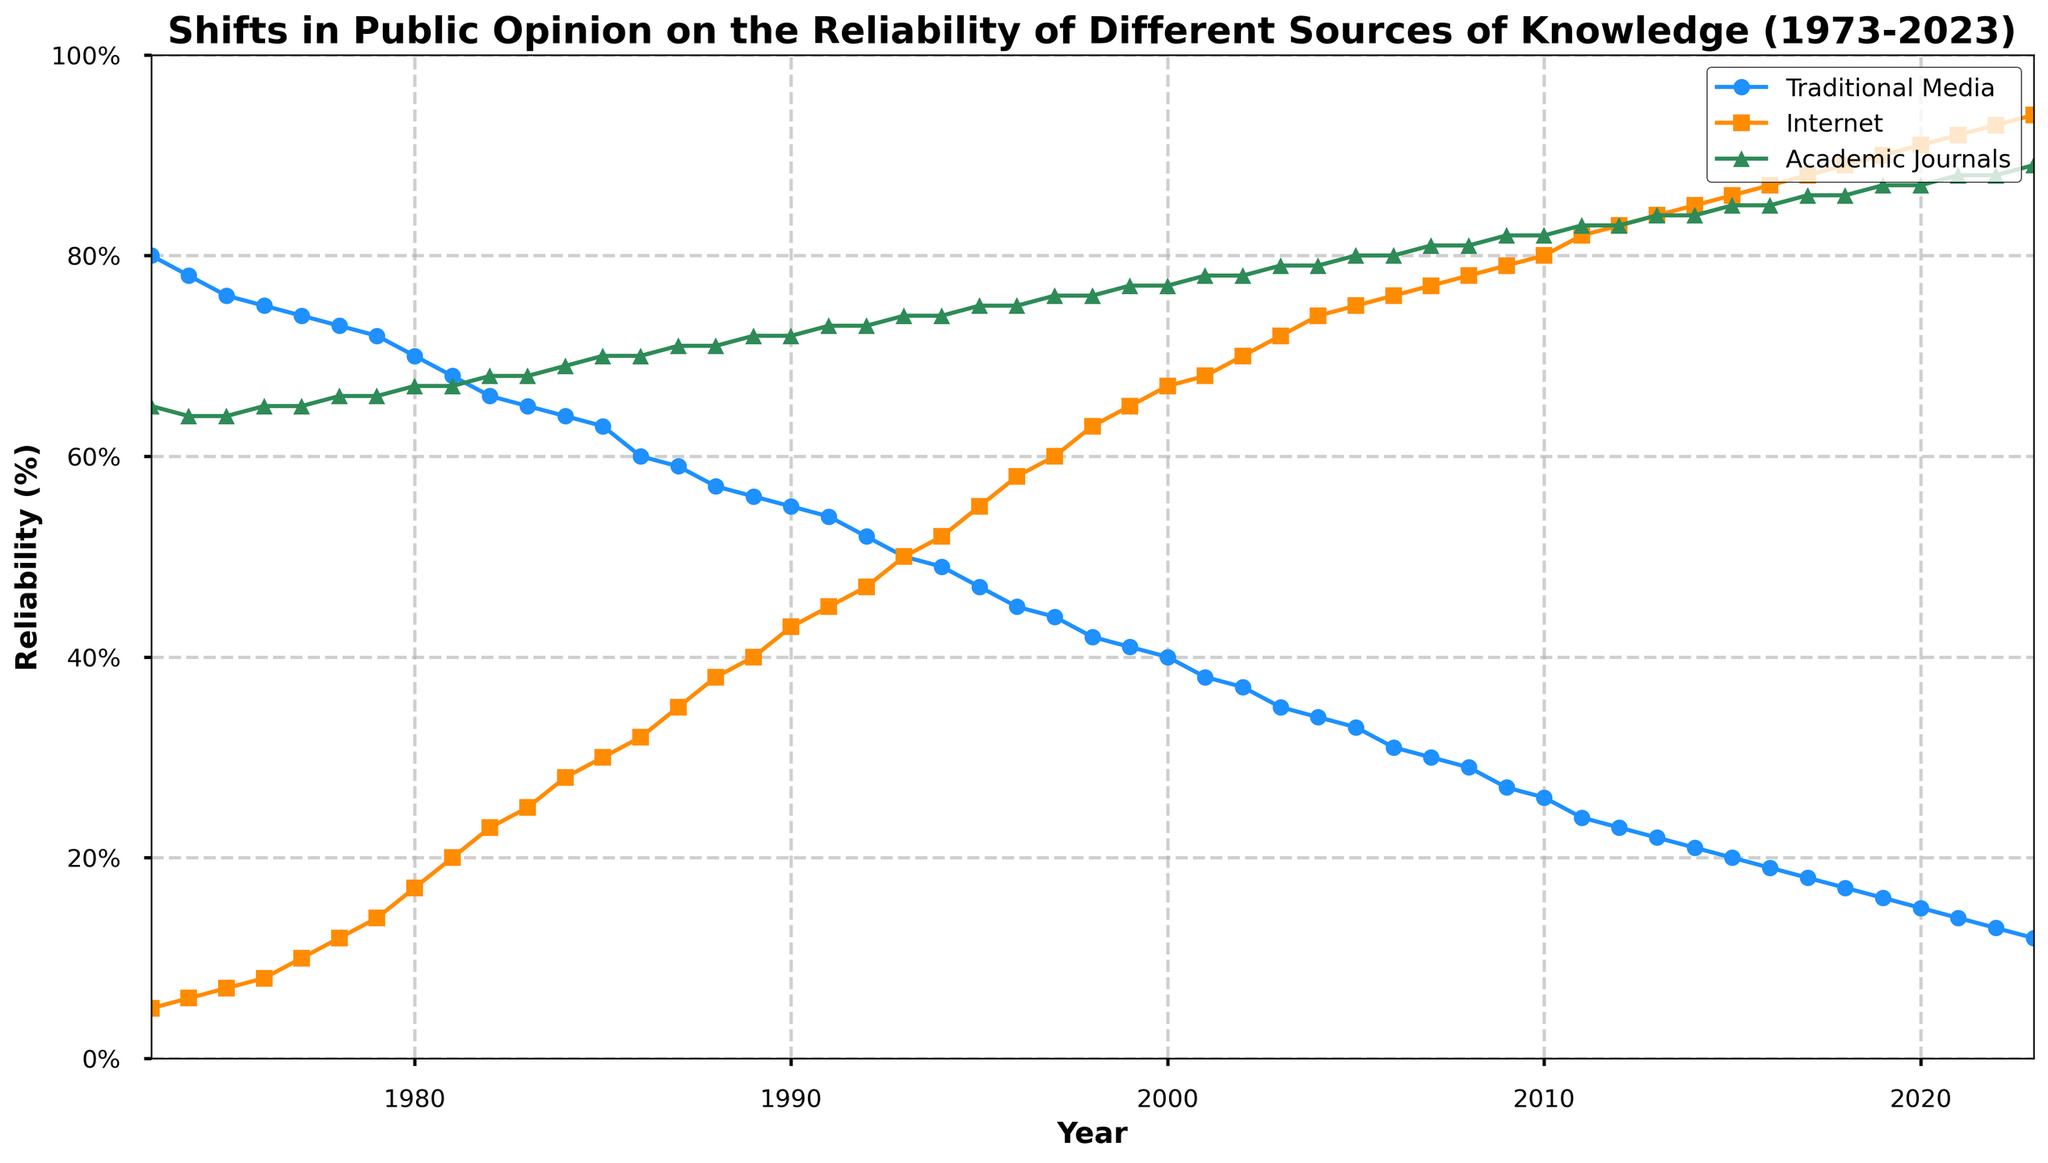What trend do you observe in the reliability of traditional media over the last 50 years? By looking at the blue line representing traditional media, we can see a clear downward trend from 80% in 1973 to 12% in 2023.
Answer: Downward trend Which source of knowledge had the most reliable perception in 2023? By comparing the end points of each line in 2023, academic journals (green line) are at 89%, which is higher than both traditional media (12%) and the internet (94%).
Answer: Internet In which year did the public opinion on the reliability of the internet surpass traditional media? By examining the intersection of the orange and blue lines, we can see that the internet (orange line) surpassed traditional media (blue line) around 1995.
Answer: 1995 What is the difference in the public opinion on the reliability of academic journals between 1973 and 2023? In 1973, the reliability was 65%, and in 2023, it is 89%. The difference is calculated as 89% - 65% = 24%.
Answer: 24% During which period did traditional media's reliability decrease most sharply? Observing the blue line, the steepest decline occurs between 1983 (65%) and 1986 (59%).
Answer: 1983-1986 What was the average reliability of the internet between 1983 and 1993? The reliability percentages of the internet from 1983 (25%) to 1993 (50%) sum up to 25 + 28 + 30 + 32 + 35 + 38 + 40 + 43 + 45 + 47 + 50 = 413%. Dividing by 11 years gives an average of 413/11 ≈ 37.5%.
Answer: 37.5% How does the reliability perception of academic journals compare from 2003 to 2013? For academic journals, the reliability increased from 79% in 2003 to 84% in 2013, showing an increment of 84% - 79% = 5%.
Answer: 5% increase Which year exhibits the intersection of the internet and academic journals reliability? Visual inspection of the orange and green lines shows they intersect around 2009, both being around 82% at that point.
Answer: 2009 Identify the period where the reliability of academic journals remained constant. From 2012 to 2014, the green line remains at 83%, indicating no change in perceived reliability during those years.
Answer: 2012-2014 What colors represent the three sources of knowledge in the plot? According to the visual attributes: traditional media is marked in blue, the internet in orange, and academic journals in green.
Answer: Blue, Orange, Green 